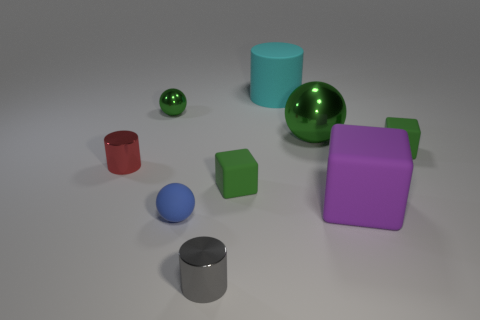Do the tiny ball that is behind the small blue sphere and the cube left of the big cyan matte cylinder have the same color?
Provide a succinct answer. Yes. What is the material of the gray object that is to the left of the metal thing on the right side of the small gray cylinder?
Provide a succinct answer. Metal. What number of other objects are there of the same color as the matte cylinder?
Offer a terse response. 0. Is the number of small shiny balls that are behind the big block less than the number of objects that are left of the blue matte thing?
Keep it short and to the point. Yes. How many things are either large things right of the big cyan matte cylinder or purple rubber things?
Your response must be concise. 2. Is the size of the purple matte cube the same as the rubber thing behind the big green shiny thing?
Keep it short and to the point. Yes. There is another rubber thing that is the same shape as the tiny red thing; what is its size?
Ensure brevity in your answer.  Large. What number of purple objects are in front of the metal sphere that is on the right side of the small metal cylinder that is in front of the blue matte thing?
Provide a succinct answer. 1. What number of balls are tiny blue metal things or tiny objects?
Offer a very short reply. 2. What is the color of the big matte object that is in front of the green metallic ball that is on the right side of the tiny green object that is behind the big green object?
Make the answer very short. Purple. 